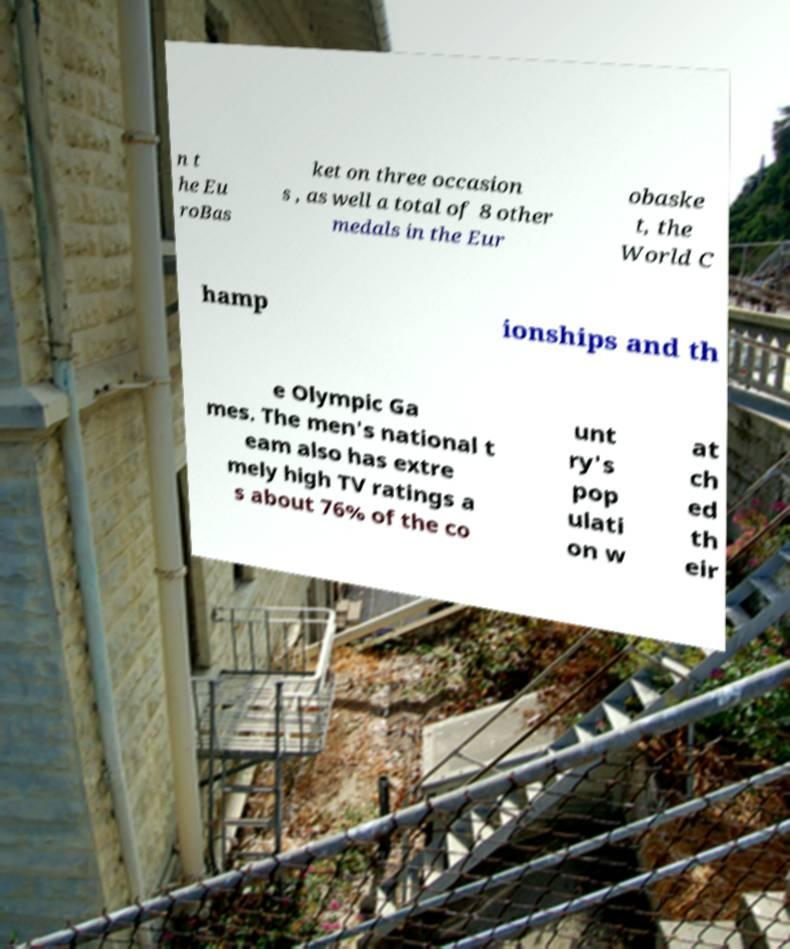Please read and relay the text visible in this image. What does it say? n t he Eu roBas ket on three occasion s , as well a total of 8 other medals in the Eur obaske t, the World C hamp ionships and th e Olympic Ga mes. The men's national t eam also has extre mely high TV ratings a s about 76% of the co unt ry's pop ulati on w at ch ed th eir 